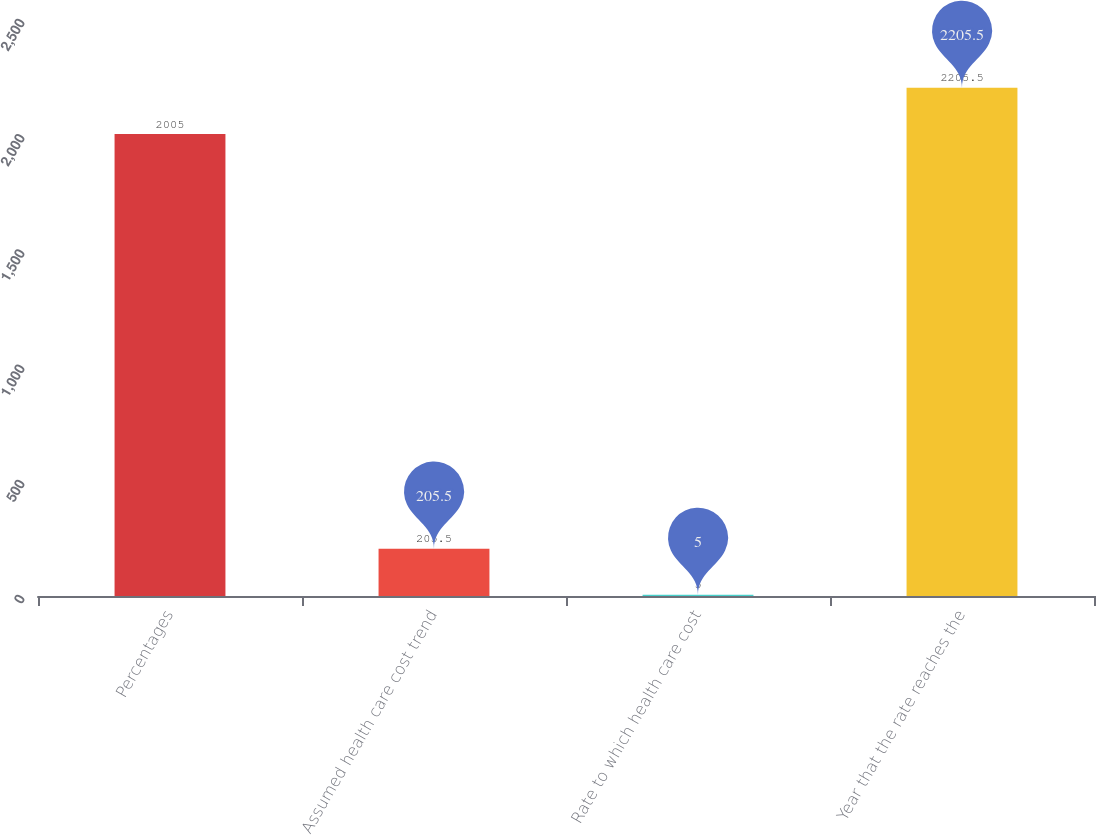Convert chart. <chart><loc_0><loc_0><loc_500><loc_500><bar_chart><fcel>Percentages<fcel>Assumed health care cost trend<fcel>Rate to which health care cost<fcel>Year that the rate reaches the<nl><fcel>2005<fcel>205.5<fcel>5<fcel>2205.5<nl></chart> 